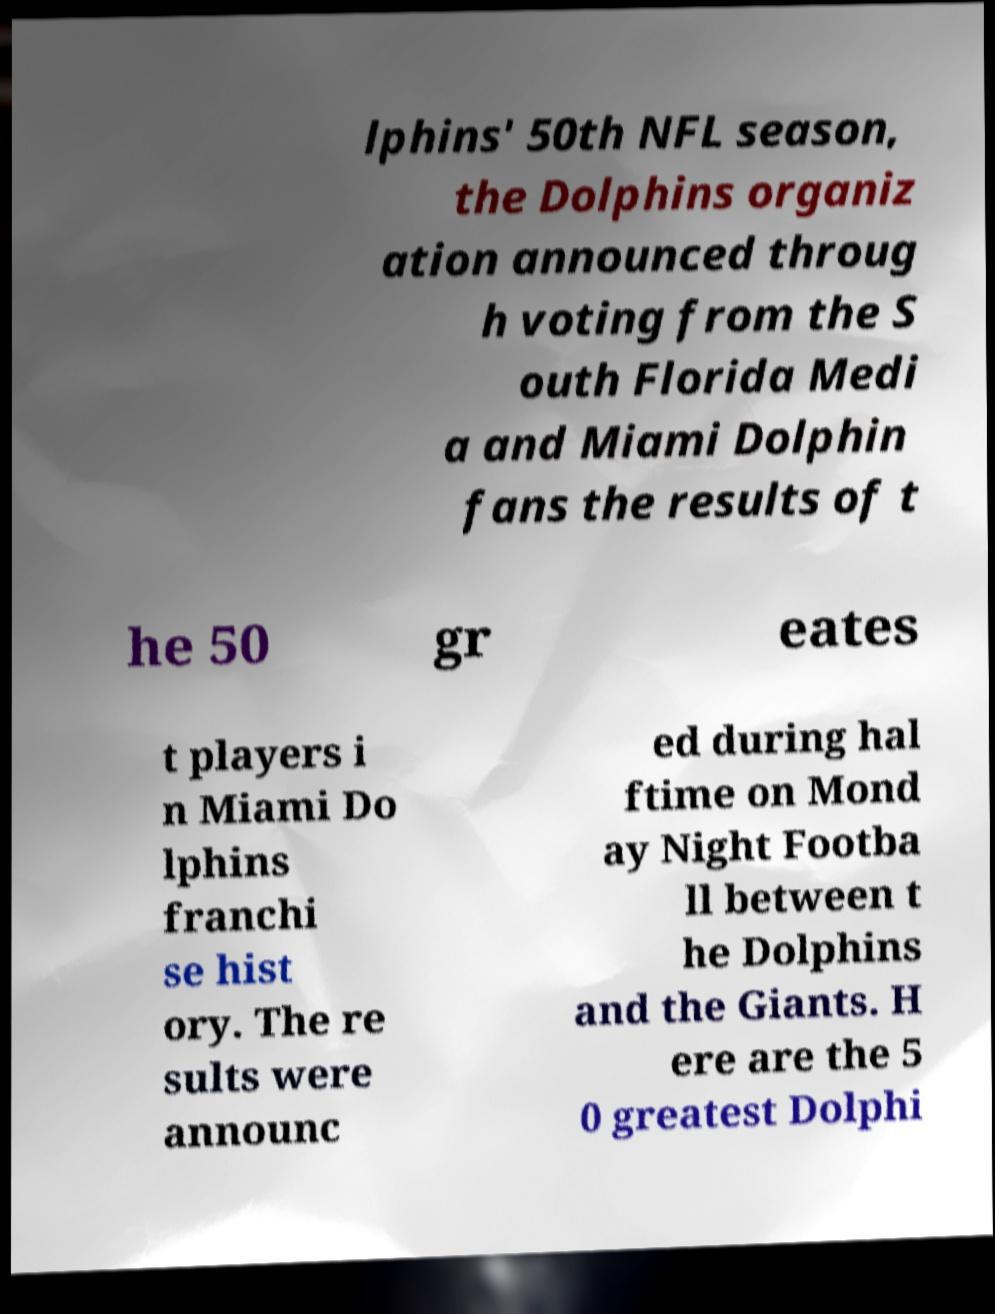Please identify and transcribe the text found in this image. lphins' 50th NFL season, the Dolphins organiz ation announced throug h voting from the S outh Florida Medi a and Miami Dolphin fans the results of t he 50 gr eates t players i n Miami Do lphins franchi se hist ory. The re sults were announc ed during hal ftime on Mond ay Night Footba ll between t he Dolphins and the Giants. H ere are the 5 0 greatest Dolphi 